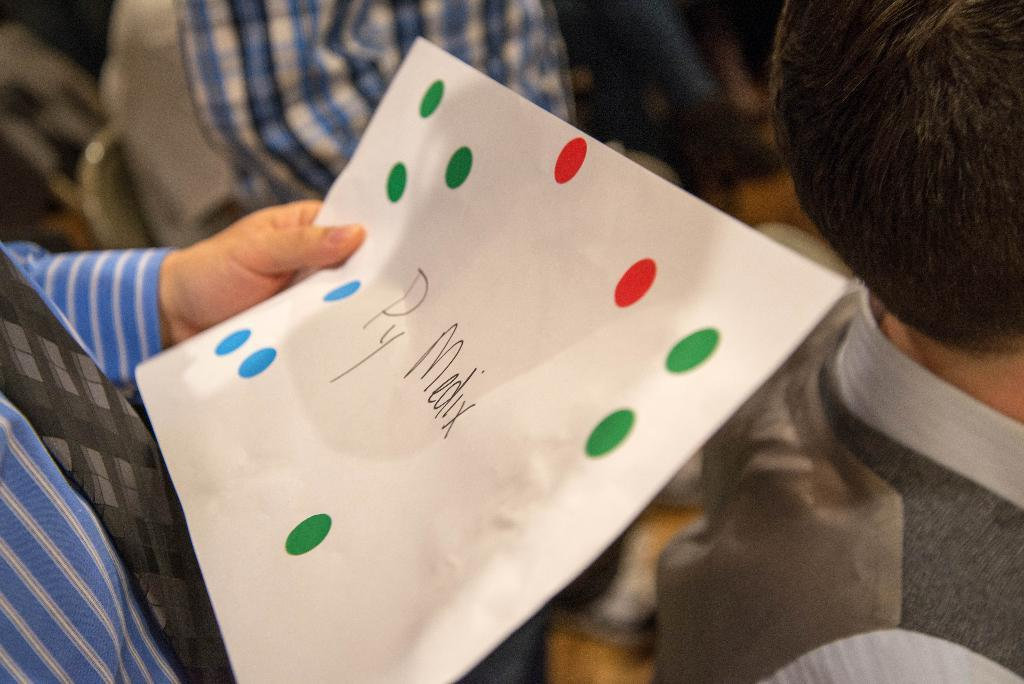What is the person in the image holding? The person is holding a paper in the image. Can you describe the paper? There are two words on the paper. What else can be seen in the image? There is a group of people in the background of the image. What nation is the person's partner from in the image? There is no information about a partner or their nationality in the image. 